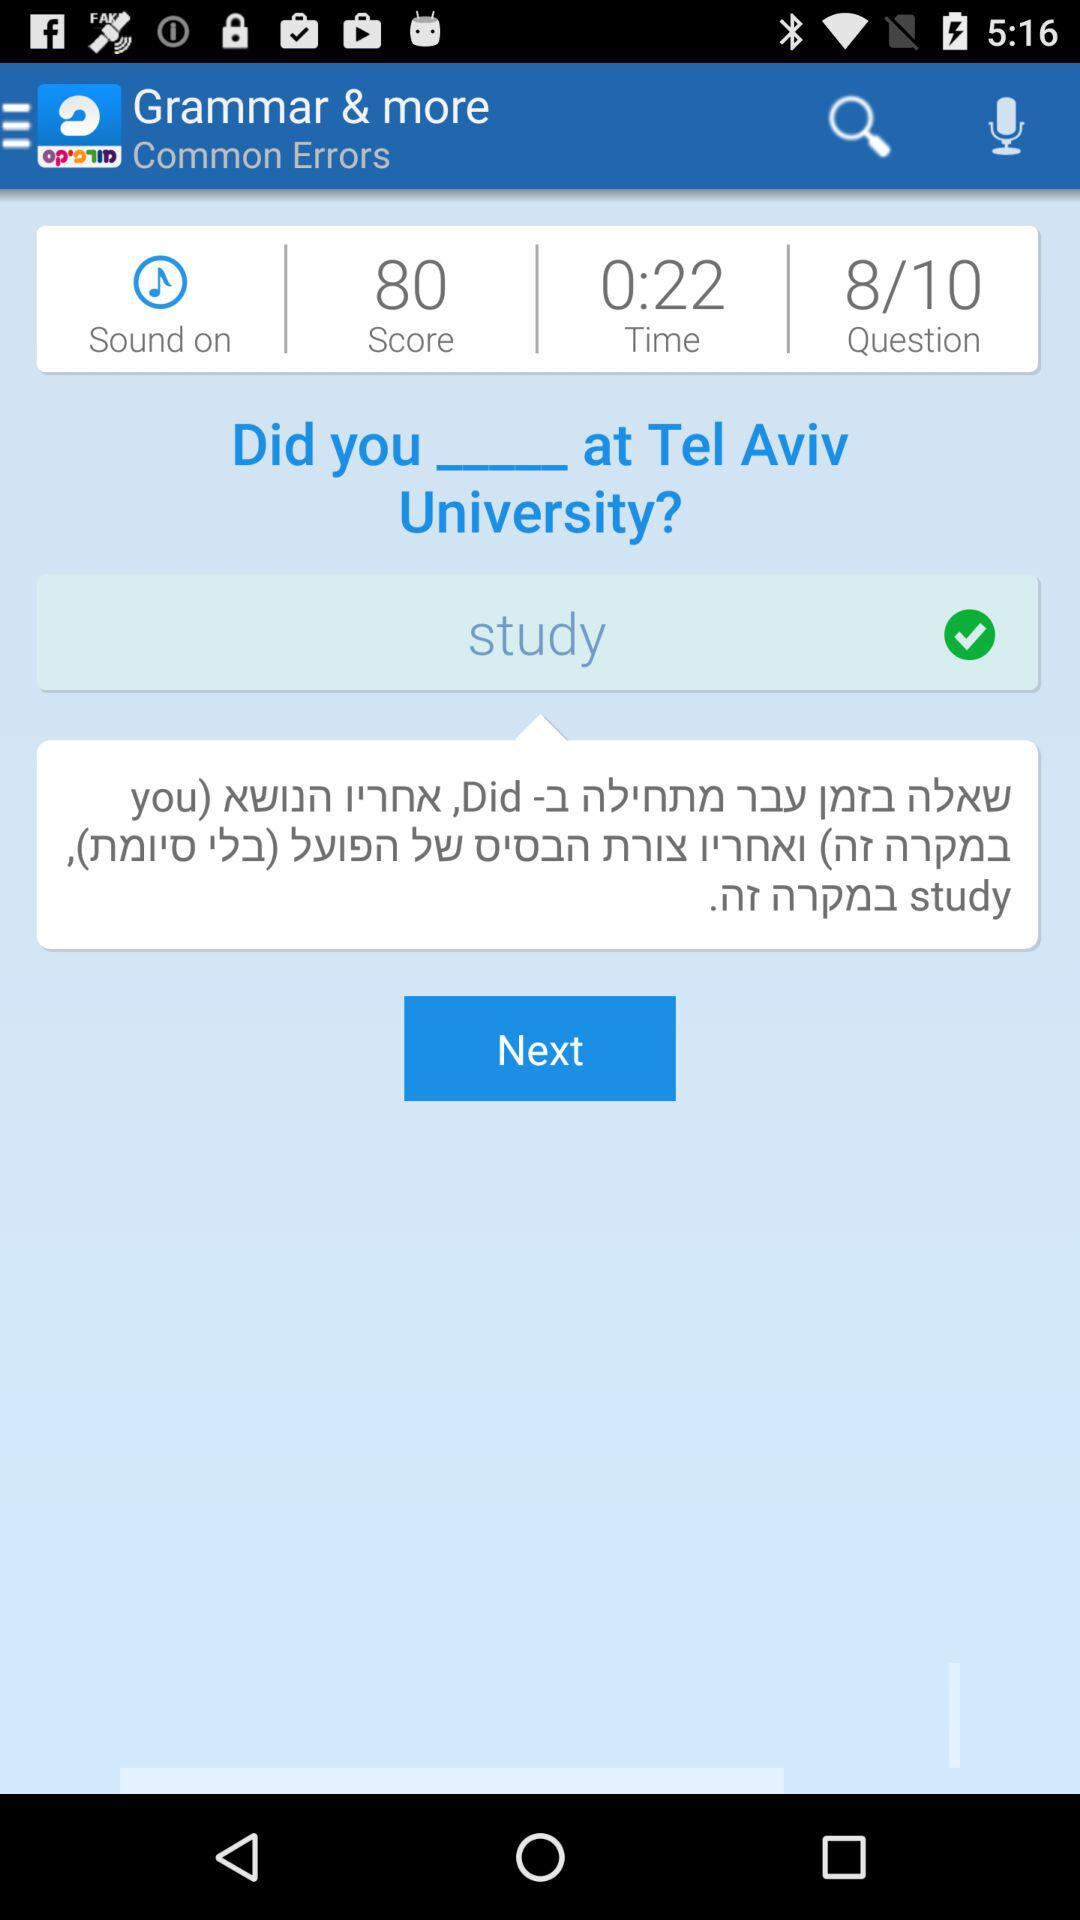What is the score? The score is 80. 